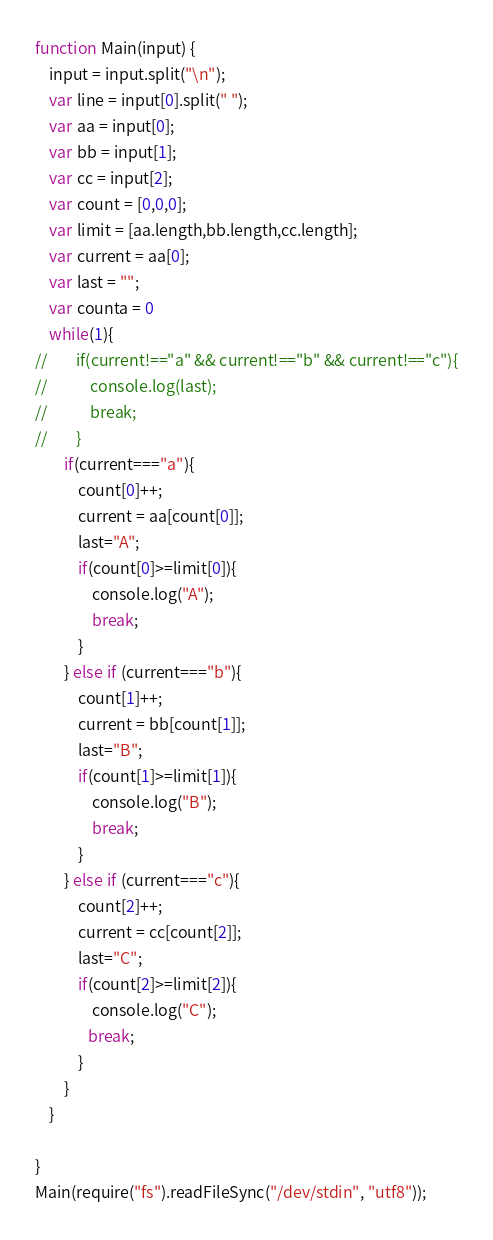Convert code to text. <code><loc_0><loc_0><loc_500><loc_500><_JavaScript_>function Main(input) {
    input = input.split("\n");
    var line = input[0].split(" ");
    var aa = input[0];
    var bb = input[1];
    var cc = input[2];
    var count = [0,0,0];
    var limit = [aa.length,bb.length,cc.length];
    var current = aa[0];
    var last = "";
    var counta = 0
    while(1){
//        if(current!=="a" && current!=="b" && current!=="c"){
//            console.log(last);
//            break;
//        }
        if(current==="a"){
            count[0]++;
            current = aa[count[0]];
            last="A";
            if(count[0]>=limit[0]){
                console.log("A");
                break;
            }
        } else if (current==="b"){
            count[1]++;
            current = bb[count[1]];
            last="B";
            if(count[1]>=limit[1]){
                console.log("B");
                break;
            }
        } else if (current==="c"){
            count[2]++;
            current = cc[count[2]];
            last="C";
            if(count[2]>=limit[2]){
                console.log("C");
               break;
            }
        }
    }
 
}
Main(require("fs").readFileSync("/dev/stdin", "utf8"));</code> 